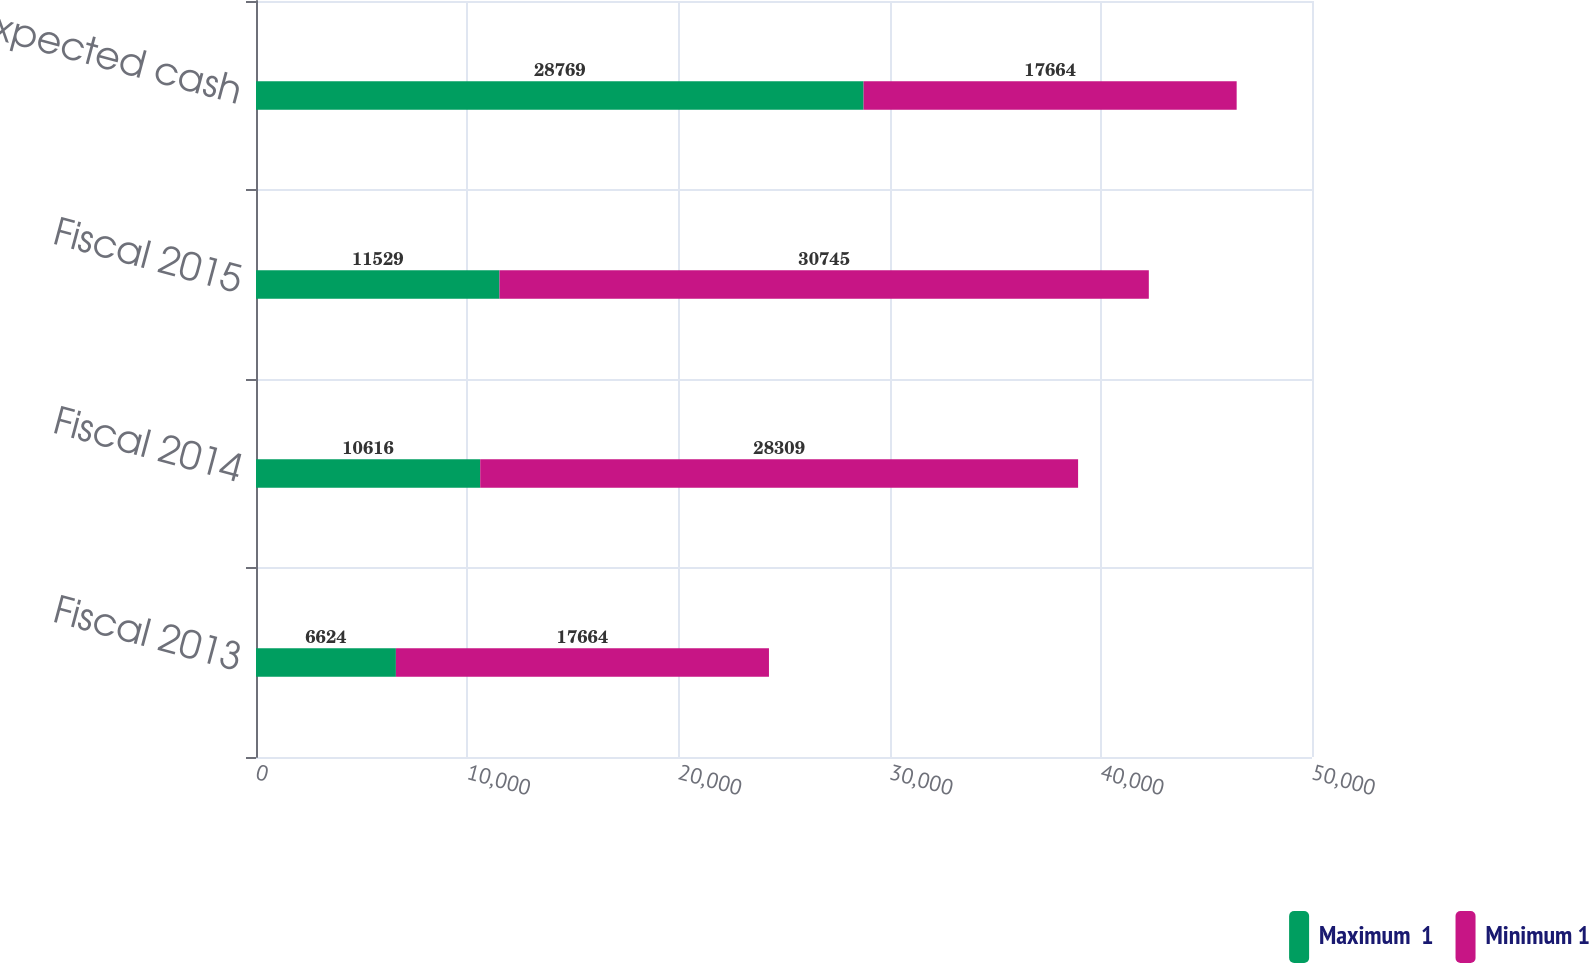Convert chart. <chart><loc_0><loc_0><loc_500><loc_500><stacked_bar_chart><ecel><fcel>Fiscal 2013<fcel>Fiscal 2014<fcel>Fiscal 2015<fcel>Total expected cash<nl><fcel>Maximum  1<fcel>6624<fcel>10616<fcel>11529<fcel>28769<nl><fcel>Minimum 1<fcel>17664<fcel>28309<fcel>30745<fcel>17664<nl></chart> 